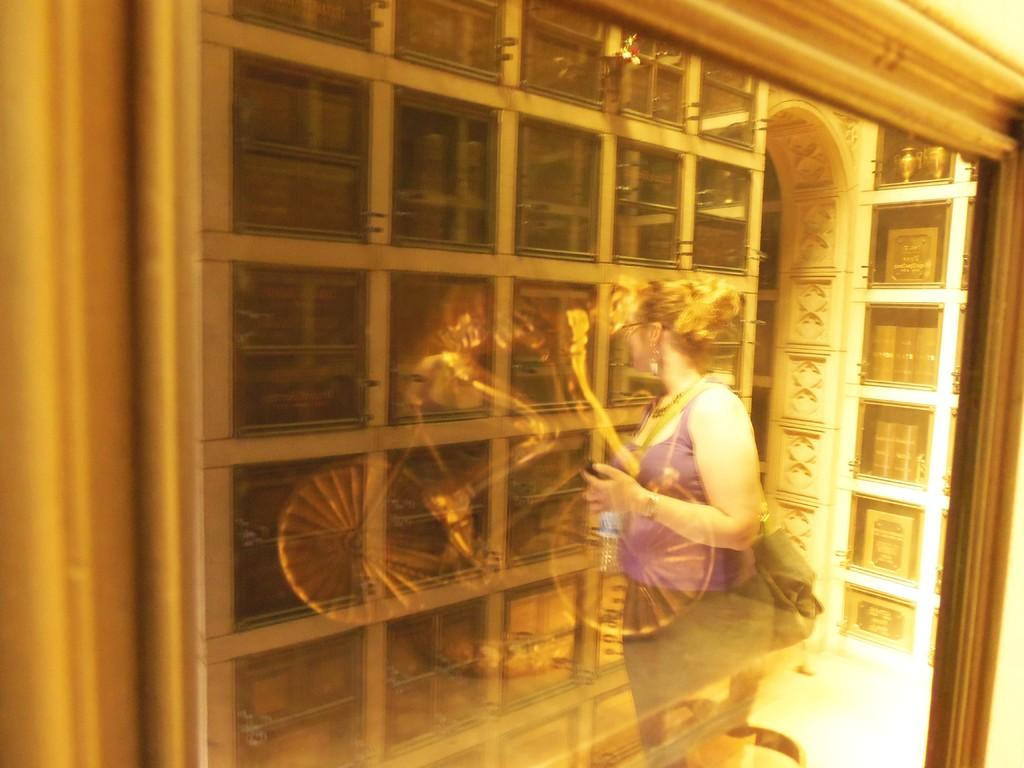What is the main subject of the image? The main subject of the image is a frame. What is depicted within the frame? The frame contains a sculpture of a person riding a bicycle. Is there anything else notable in the image? Yes, there is a reflection of a woman standing in the image. What type of rhythm can be heard coming from the trucks in the image? There are no trucks present in the image, so it's not possible to determine what, if any, rhythm might be heard. 